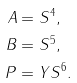<formula> <loc_0><loc_0><loc_500><loc_500>A & = S ^ { 4 } , \\ B & = S ^ { 5 } , \\ P & = Y S ^ { 6 } .</formula> 